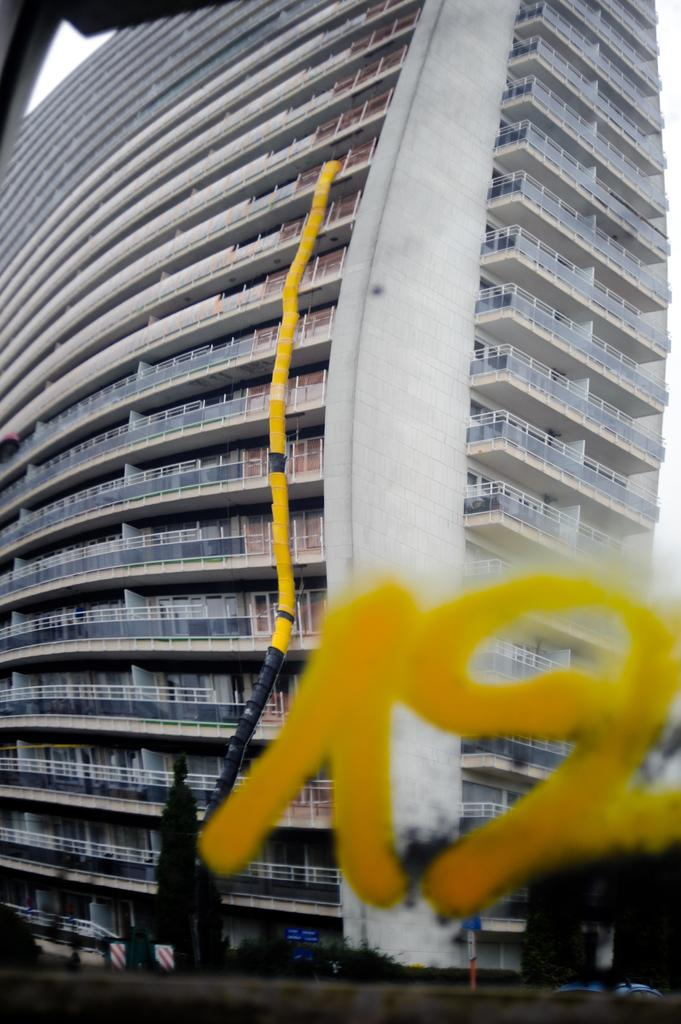What type of structure is visible in the image? There is a building in the image. What can be seen in front of the building? There are trees in front of the building in the image. What year is the alarm set to in the image? There is no alarm present in the image, so it is not possible to determine the year it is set to. 